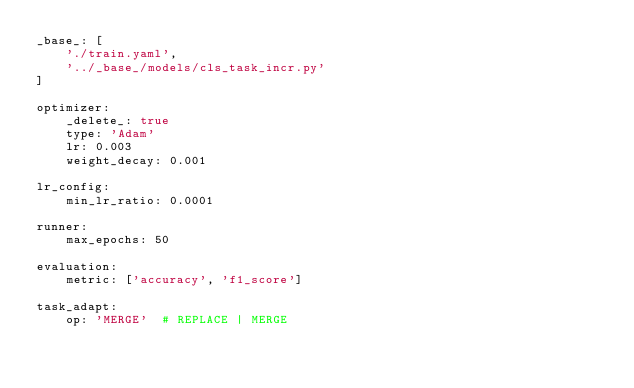Convert code to text. <code><loc_0><loc_0><loc_500><loc_500><_YAML_>_base_: [
    './train.yaml',
    '../_base_/models/cls_task_incr.py'
]

optimizer:
    _delete_: true
    type: 'Adam'
    lr: 0.003
    weight_decay: 0.001

lr_config:
    min_lr_ratio: 0.0001

runner:
    max_epochs: 50

evaluation:
    metric: ['accuracy', 'f1_score']

task_adapt:
    op: 'MERGE'  # REPLACE | MERGE</code> 